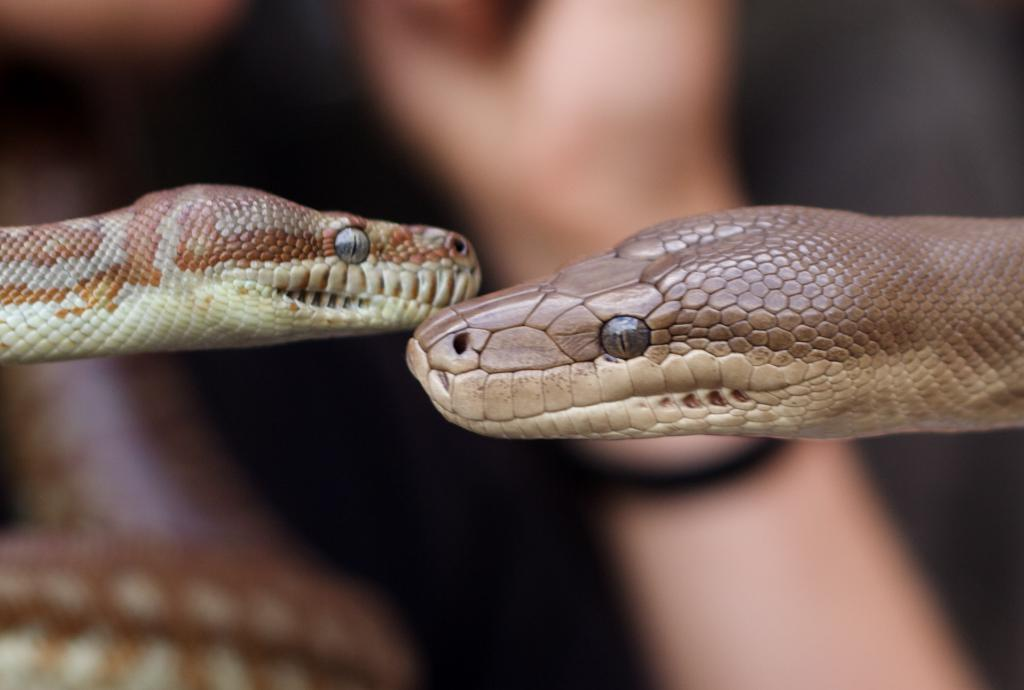What type of animals are present in the image? There are snakes in the image. Can you describe the setting of the image? There is a person in the background of the image. What type of cherry is being sold by the person in the image? There is no cherry present in the image, and the person is not selling anything. 